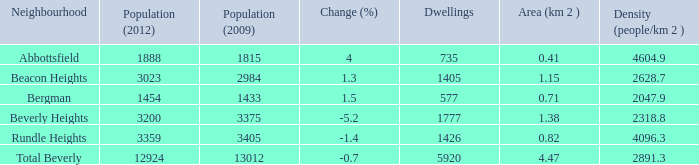Could you parse the entire table as a dict? {'header': ['Neighbourhood', 'Population (2012)', 'Population (2009)', 'Change (%)', 'Dwellings', 'Area (km 2 )', 'Density (people/km 2 )'], 'rows': [['Abbottsfield', '1888', '1815', '4', '735', '0.41', '4604.9'], ['Beacon Heights', '3023', '2984', '1.3', '1405', '1.15', '2628.7'], ['Bergman', '1454', '1433', '1.5', '577', '0.71', '2047.9'], ['Beverly Heights', '3200', '3375', '-5.2', '1777', '1.38', '2318.8'], ['Rundle Heights', '3359', '3405', '-1.4', '1426', '0.82', '4096.3'], ['Total Beverly', '12924', '13012', '-0.7', '5920', '4.47', '2891.3']]} 38km and with more than 12924 residents? 0.0. 